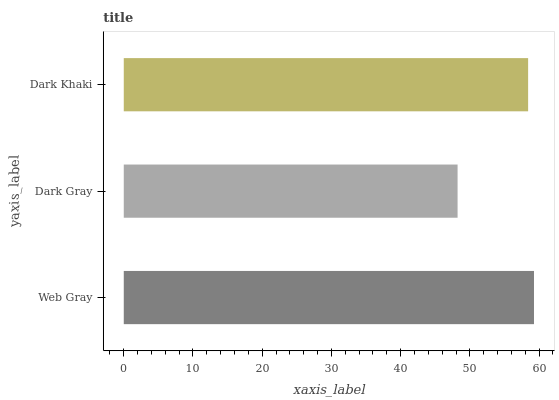Is Dark Gray the minimum?
Answer yes or no. Yes. Is Web Gray the maximum?
Answer yes or no. Yes. Is Dark Khaki the minimum?
Answer yes or no. No. Is Dark Khaki the maximum?
Answer yes or no. No. Is Dark Khaki greater than Dark Gray?
Answer yes or no. Yes. Is Dark Gray less than Dark Khaki?
Answer yes or no. Yes. Is Dark Gray greater than Dark Khaki?
Answer yes or no. No. Is Dark Khaki less than Dark Gray?
Answer yes or no. No. Is Dark Khaki the high median?
Answer yes or no. Yes. Is Dark Khaki the low median?
Answer yes or no. Yes. Is Web Gray the high median?
Answer yes or no. No. Is Web Gray the low median?
Answer yes or no. No. 